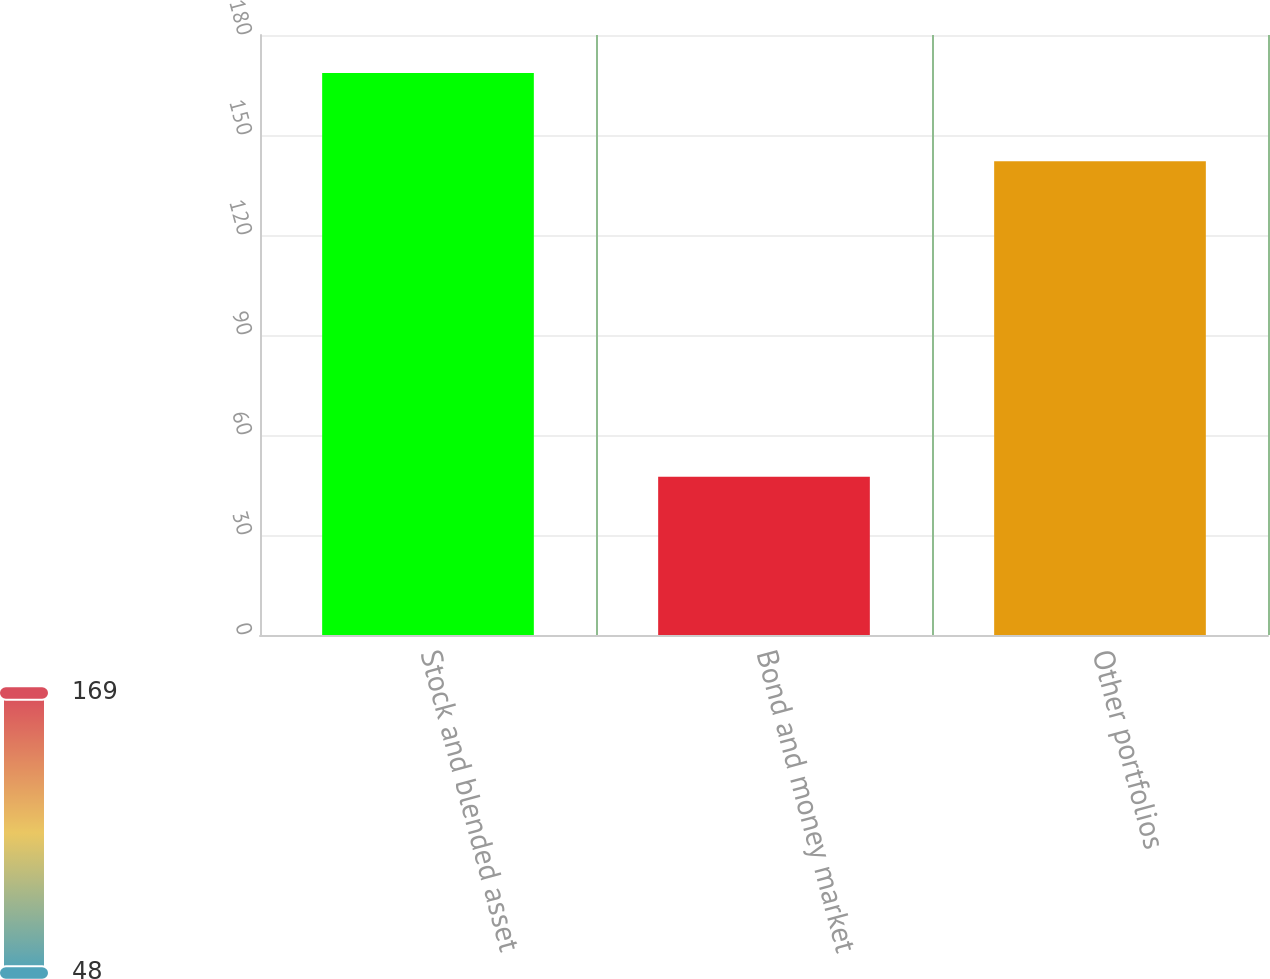Convert chart to OTSL. <chart><loc_0><loc_0><loc_500><loc_500><bar_chart><fcel>Stock and blended asset<fcel>Bond and money market<fcel>Other portfolios<nl><fcel>168.6<fcel>47.5<fcel>142.1<nl></chart> 